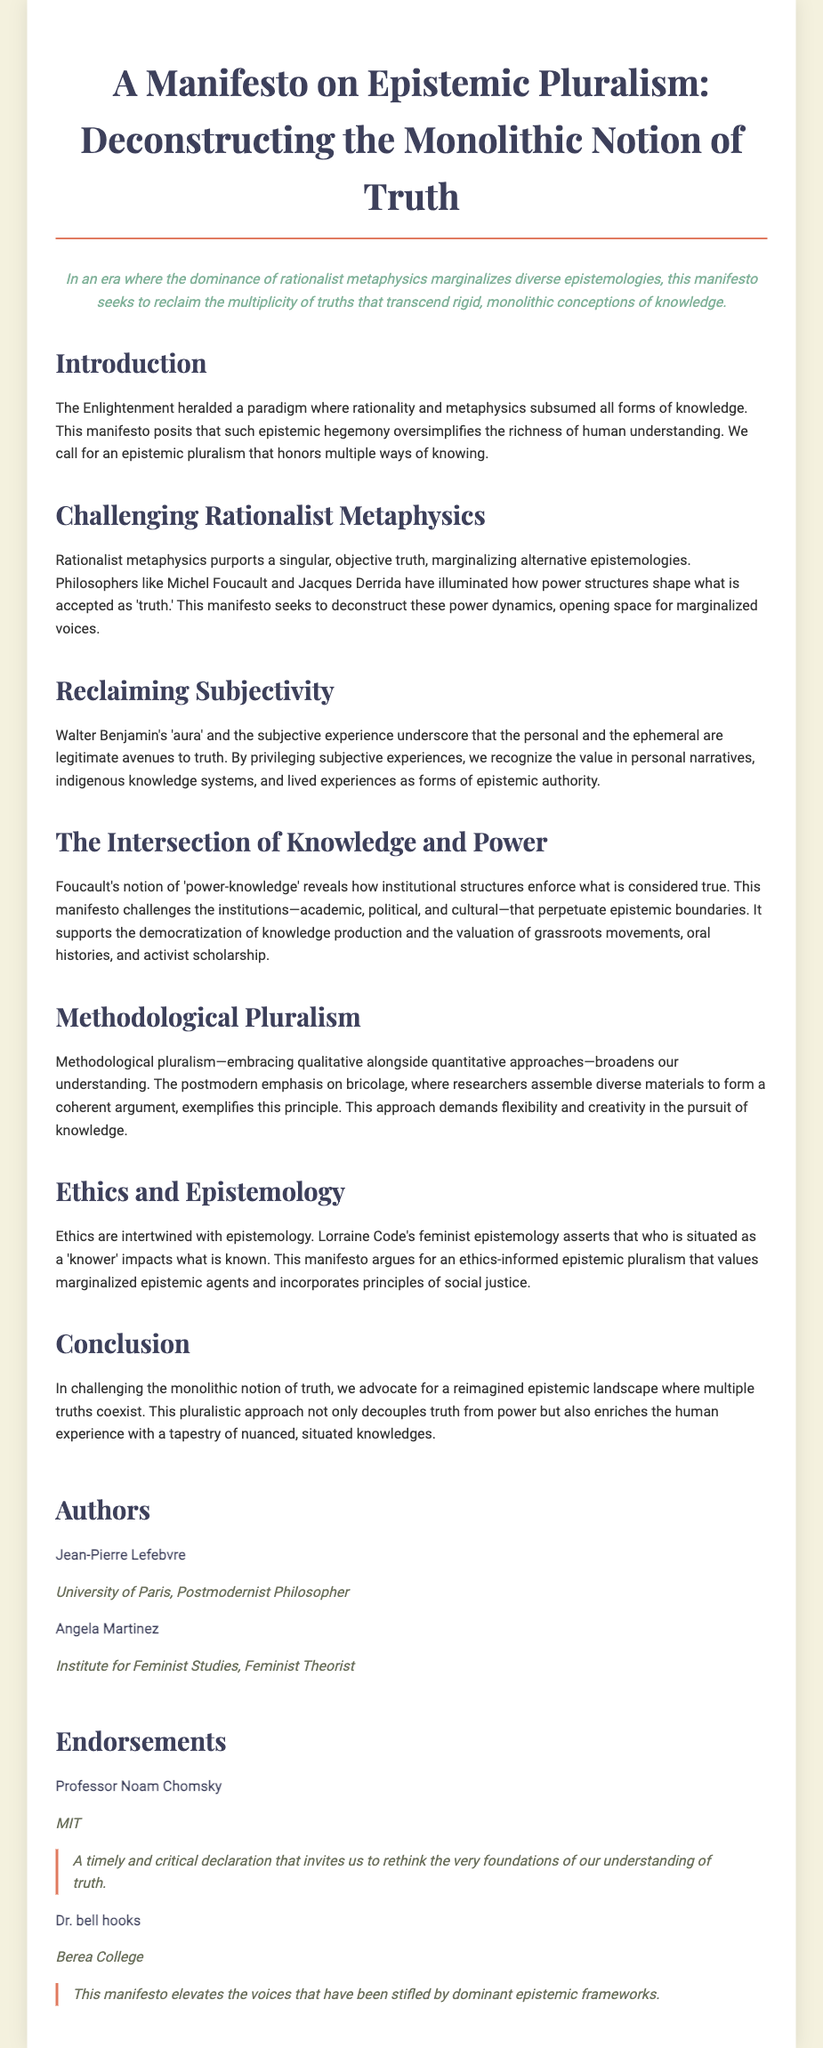what is the title of the manifesto? The title is clearly stated at the top of the document and is "A Manifesto on Epistemic Pluralism: Deconstructing the Monolithic Notion of Truth."
Answer: A Manifesto on Epistemic Pluralism: Deconstructing the Monolithic Notion of Truth who is one of the authors of the manifesto? The authors section lists two individuals, one of whom is Jean-Pierre Lefebvre.
Answer: Jean-Pierre Lefebvre what concept does Foucault's notion reveal in the document? The document discusses Foucault's notion of 'power-knowledge' which describes how institutional structures enforce what is considered true.
Answer: power-knowledge how many sections does the document have? The document consists of six main sections.
Answer: six what does this manifesto argue for in relation to epistemology? The manifesto asserts a specific position regarding epistemology, emphasizing the importance of social justice and marginalized epistemic agents.
Answer: ethics-informed epistemic pluralism who endorsed the manifesto? The document mentions several endorsers, including Professor Noam Chomsky, who supports the declaration.
Answer: Professor Noam Chomsky what is the purpose of the manifesto? The document clearly articulates its purpose which is to reclaim the multiplicity of truths and challenge the oversimplification of knowledge.
Answer: reclaim the multiplicity of truths in which university is author Angela Martinez affiliated? The information about author Angela Martinez includes her affiliation with a specific institution, which is indicated in the document.
Answer: Institute for Feminist Studies 